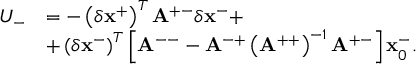<formula> <loc_0><loc_0><loc_500><loc_500>\begin{array} { r l } { U _ { - } } & { = - \left ( \delta x ^ { + } \right ) ^ { T } A ^ { + - } \delta x ^ { - } + } \\ & { + \left ( \delta x ^ { - } \right ) ^ { T } \left [ A ^ { - - } - A ^ { - + } \left ( A ^ { + + } \right ) ^ { - 1 } A ^ { + - } \right ] x _ { 0 } ^ { - } . } \end{array}</formula> 